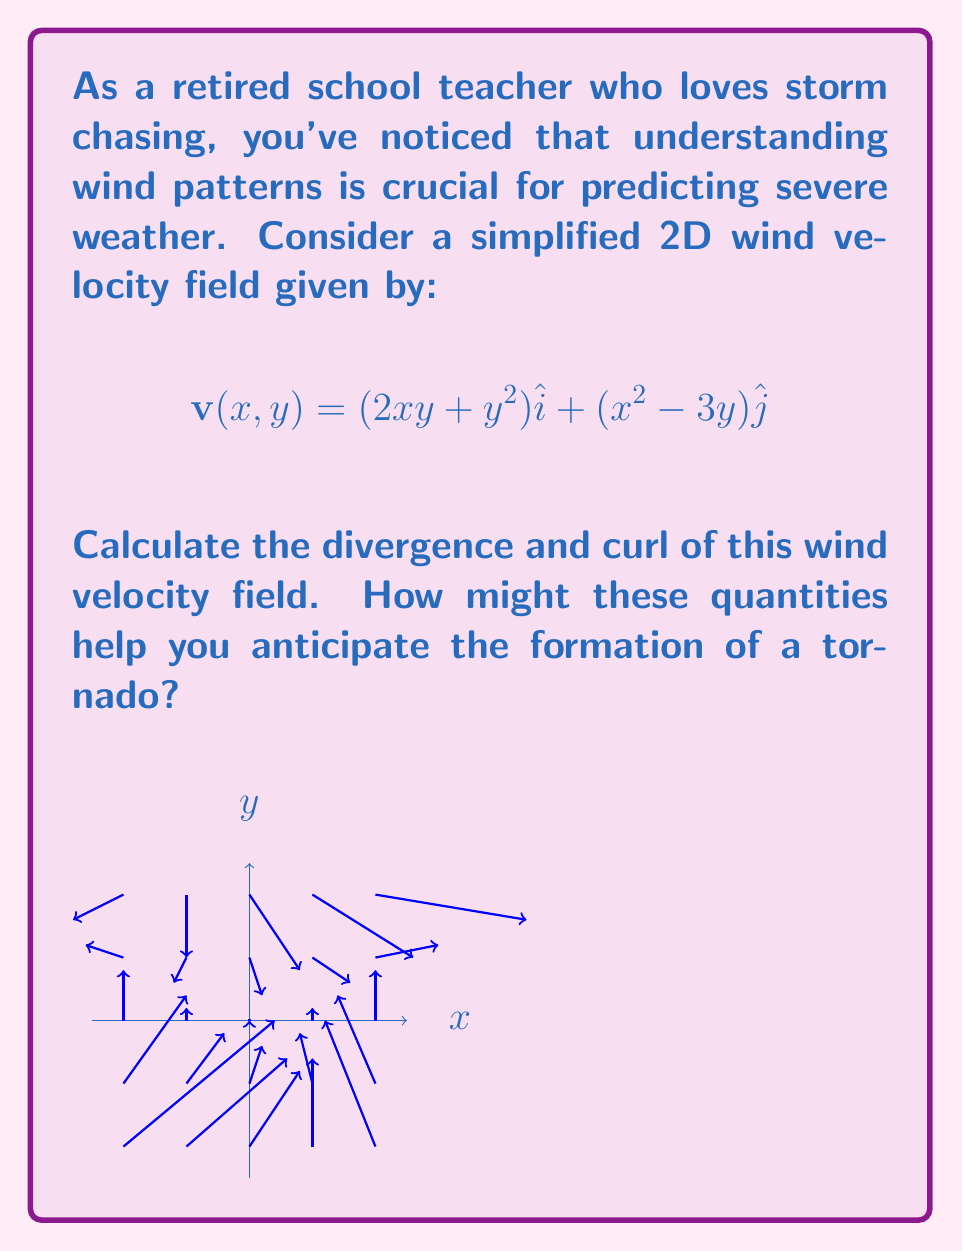Give your solution to this math problem. Let's approach this step-by-step:

1) The divergence of a 2D vector field $\mathbf{v}(x,y) = P(x,y)\hat{i} + Q(x,y)\hat{j}$ is given by:

   $$\text{div }\mathbf{v} = \nabla \cdot \mathbf{v} = \frac{\partial P}{\partial x} + \frac{\partial Q}{\partial y}$$

2) In our case, $P(x,y) = 2xy + y^2$ and $Q(x,y) = x^2 - 3y$. Let's calculate the partial derivatives:

   $$\frac{\partial P}{\partial x} = 2y$$
   $$\frac{\partial Q}{\partial y} = -3$$

3) Now, we can calculate the divergence:

   $$\text{div }\mathbf{v} = 2y + (-3) = 2y - 3$$

4) The curl of a 2D vector field in the z-direction is given by:

   $$\text{curl }\mathbf{v} = \nabla \times \mathbf{v} = \left(\frac{\partial Q}{\partial x} - \frac{\partial P}{\partial y}\right)\hat{k}$$

5) Let's calculate these partial derivatives:

   $$\frac{\partial Q}{\partial x} = 2x$$
   $$\frac{\partial P}{\partial y} = 2x + 2y$$

6) Now, we can calculate the curl:

   $$\text{curl }\mathbf{v} = (2x - (2x + 2y))\hat{k} = -2y\hat{k}$$

7) Interpretation for storm chasing:
   - Divergence represents the expansion or contraction of the wind field. Positive divergence (expansion) at the surface and negative divergence (convergence) aloft can indicate rising air, potentially leading to storm formation.
   - Curl represents rotation in the wind field. Strong positive curl (counterclockwise rotation in the Northern Hemisphere) can indicate conditions favorable for tornado formation.

In this case, both divergence and curl depend on y, suggesting that the vertical position in the storm system is crucial for determining these factors.
Answer: Divergence: $2y - 3$, Curl: $-2y\hat{k}$ 